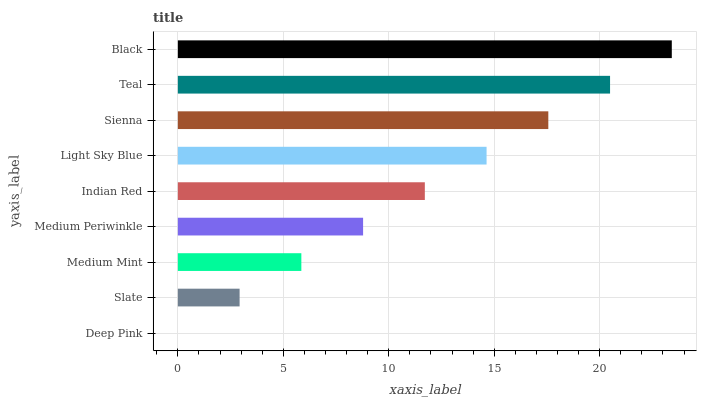Is Deep Pink the minimum?
Answer yes or no. Yes. Is Black the maximum?
Answer yes or no. Yes. Is Slate the minimum?
Answer yes or no. No. Is Slate the maximum?
Answer yes or no. No. Is Slate greater than Deep Pink?
Answer yes or no. Yes. Is Deep Pink less than Slate?
Answer yes or no. Yes. Is Deep Pink greater than Slate?
Answer yes or no. No. Is Slate less than Deep Pink?
Answer yes or no. No. Is Indian Red the high median?
Answer yes or no. Yes. Is Indian Red the low median?
Answer yes or no. Yes. Is Deep Pink the high median?
Answer yes or no. No. Is Light Sky Blue the low median?
Answer yes or no. No. 